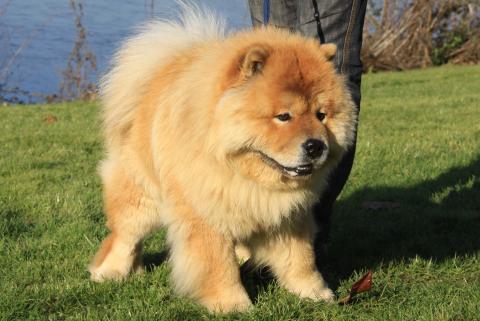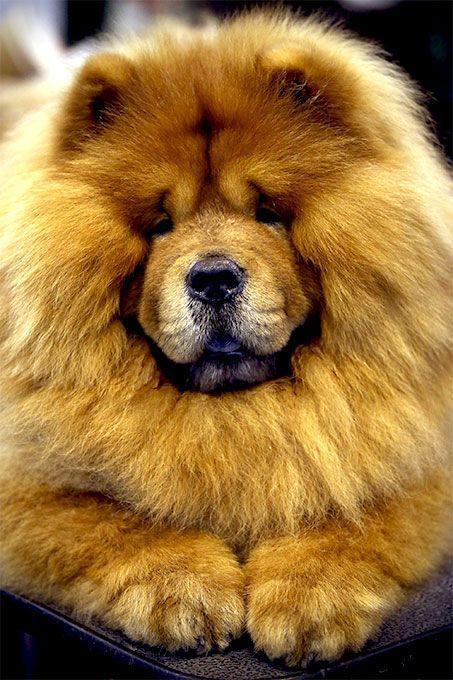The first image is the image on the left, the second image is the image on the right. Considering the images on both sides, is "You can see one dog's feet in the grass." valid? Answer yes or no. Yes. The first image is the image on the left, the second image is the image on the right. Evaluate the accuracy of this statement regarding the images: "One of the dogs is on a leash outdoors, in front of a leg clad in pants.". Is it true? Answer yes or no. Yes. 